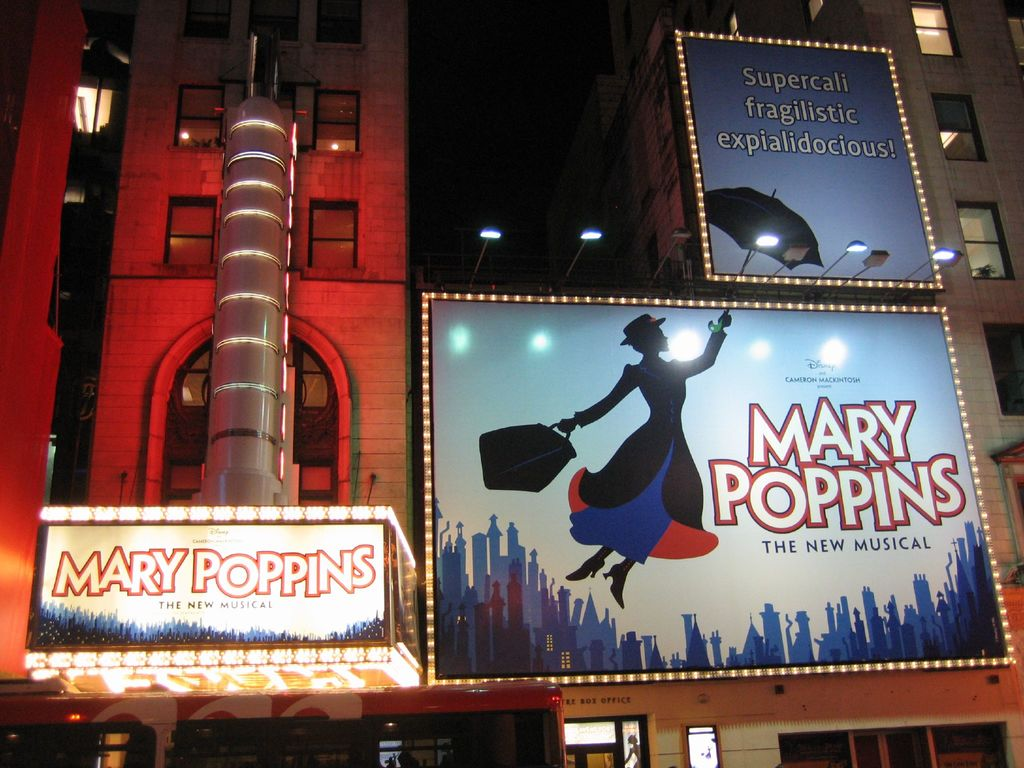What type of audience might be attracted to this event? The event showcased in the image, 'Mary Poppins The New Musical,' is likely to attract a diverse audience ranging from families with young children to older adults who cherish the classic tale. The universal themes of joy, adventure, and whimsy resonate across generations, making it appealing to anyone looking for an uplifting theater experience. The festive atmosphere depicted suggests a particularly family-friendly evening, promising fun and entertainment that can be enjoyed by all. 